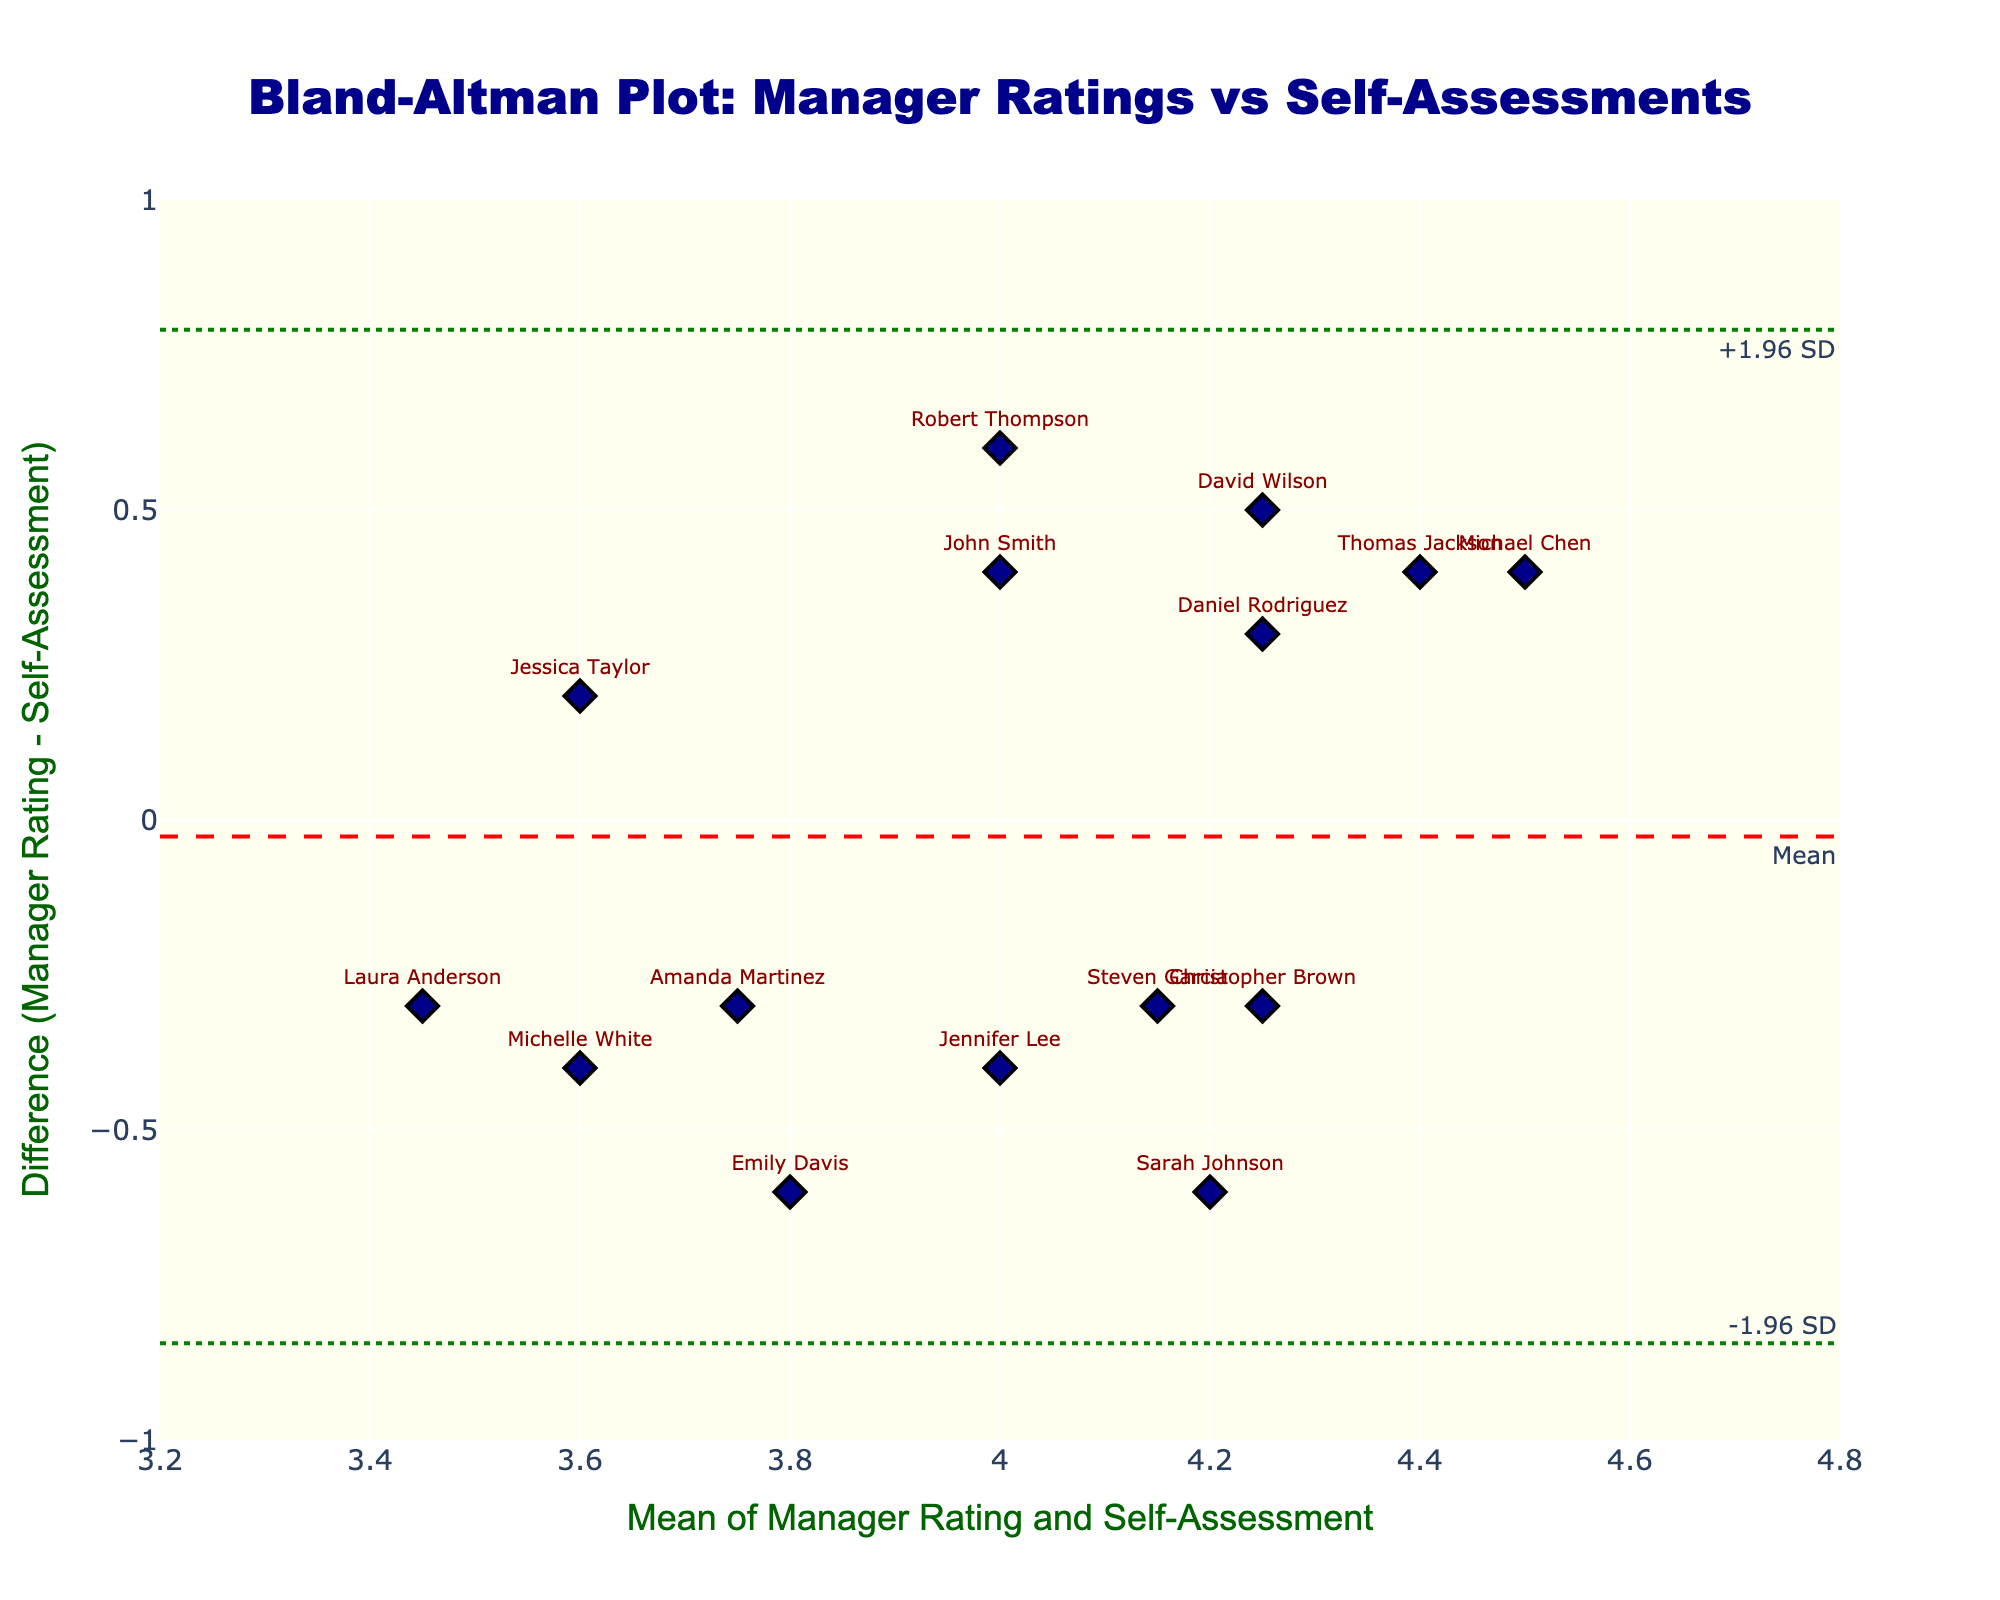What is the title of the plot? The plot title is the main text at the top of the figure. It is typically placed prominently for easy identification. In this case, the title given is "Bland-Altman Plot: Manager Ratings vs Self-Assessments."
Answer: Bland-Altman Plot: Manager Ratings vs Self-Assessments What are the labels for the X and Y axes? The X-axis title is usually at the bottom of the horizontal axis, and the Y-axis title is along the vertical axis. For this plot, the X-axis is labeled "Mean of Manager Rating and Self-Assessment," and the Y-axis is labeled "Difference (Manager Rating - Self-Assessment)."
Answer: Mean of Manager Rating and Self-Assessment; Difference (Manager Rating - Self-Assessment) How many employees are plotted in the figure? Each data point on the figure represents an individual employee. By counting the number of markers, we can determine the total number of employees plotted. The data includes 15 employees.
Answer: 15 What does the red dashed line in the plot represent? The red dashed line corresponds to the mean difference between manager ratings and self-assessments. This is a key reference value in a Bland-Altman plot to check for bias. The plot annotations also indicate this.
Answer: Mean difference What is the purpose of the upper and lower green dotted lines in the plot? The green dotted lines indicate the limits of agreement, defined as the mean difference plus or minus 1.96 times the standard deviation of the differences. These lines help assess the degree of agreement between manager ratings and self-assessments.
Answer: Limits of agreement How is the point for Sarah Johnson positioned relative to the mean difference line? The figure text annotations and markers show that Sarah Johnson's point is positioned above the mean difference line. This indicates her self-assessment is higher than her manager's rating.
Answer: Above Which employee has the largest difference between manager rating and self-assessment? By looking at the vertical distance from the mean difference line, we can determine that Emily Davis has the largest positive difference, and Robert Thompson has the largest negative difference. Emily's difference is +0.6 and Robert's is -0.6, respectively.
Answer: Emily Davis (+0.6) and Robert Thompson (-0.6) Are there more employees whose self-assessments are higher or lower than the manager ratings? Observing the distribution of points relative to the zero line in the plot will show that more points lie above the zero difference line, indicating that more employees rated themselves higher than their managers did.
Answer: Higher Which employees are within one standard deviation of the mean difference? To answer this, we need to identify employees whose ratings are within the bounds set by the mean difference ± 1 standard deviation. The figure's green lines and respective intervals highlight employees like David Wilson, Christopher Brown, Daniel Rodriguez, and others.
Answer: David Wilson, Christopher Brown, Daniel Rodriguez What can we infer if an employee's point lies beyond the green dotted lines? Points beyond the green dotted lines are outside the limits of agreement, suggesting that there is significant disparity between the manager's rating and self-assessment. These points might indicate potential issues in perception or evaluation.
Answer: Significant disparity 